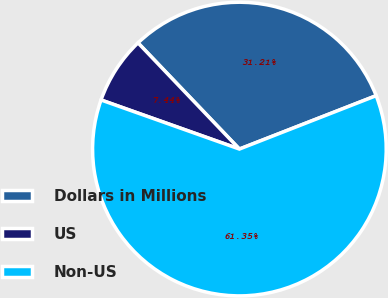Convert chart to OTSL. <chart><loc_0><loc_0><loc_500><loc_500><pie_chart><fcel>Dollars in Millions<fcel>US<fcel>Non-US<nl><fcel>31.21%<fcel>7.44%<fcel>61.35%<nl></chart> 